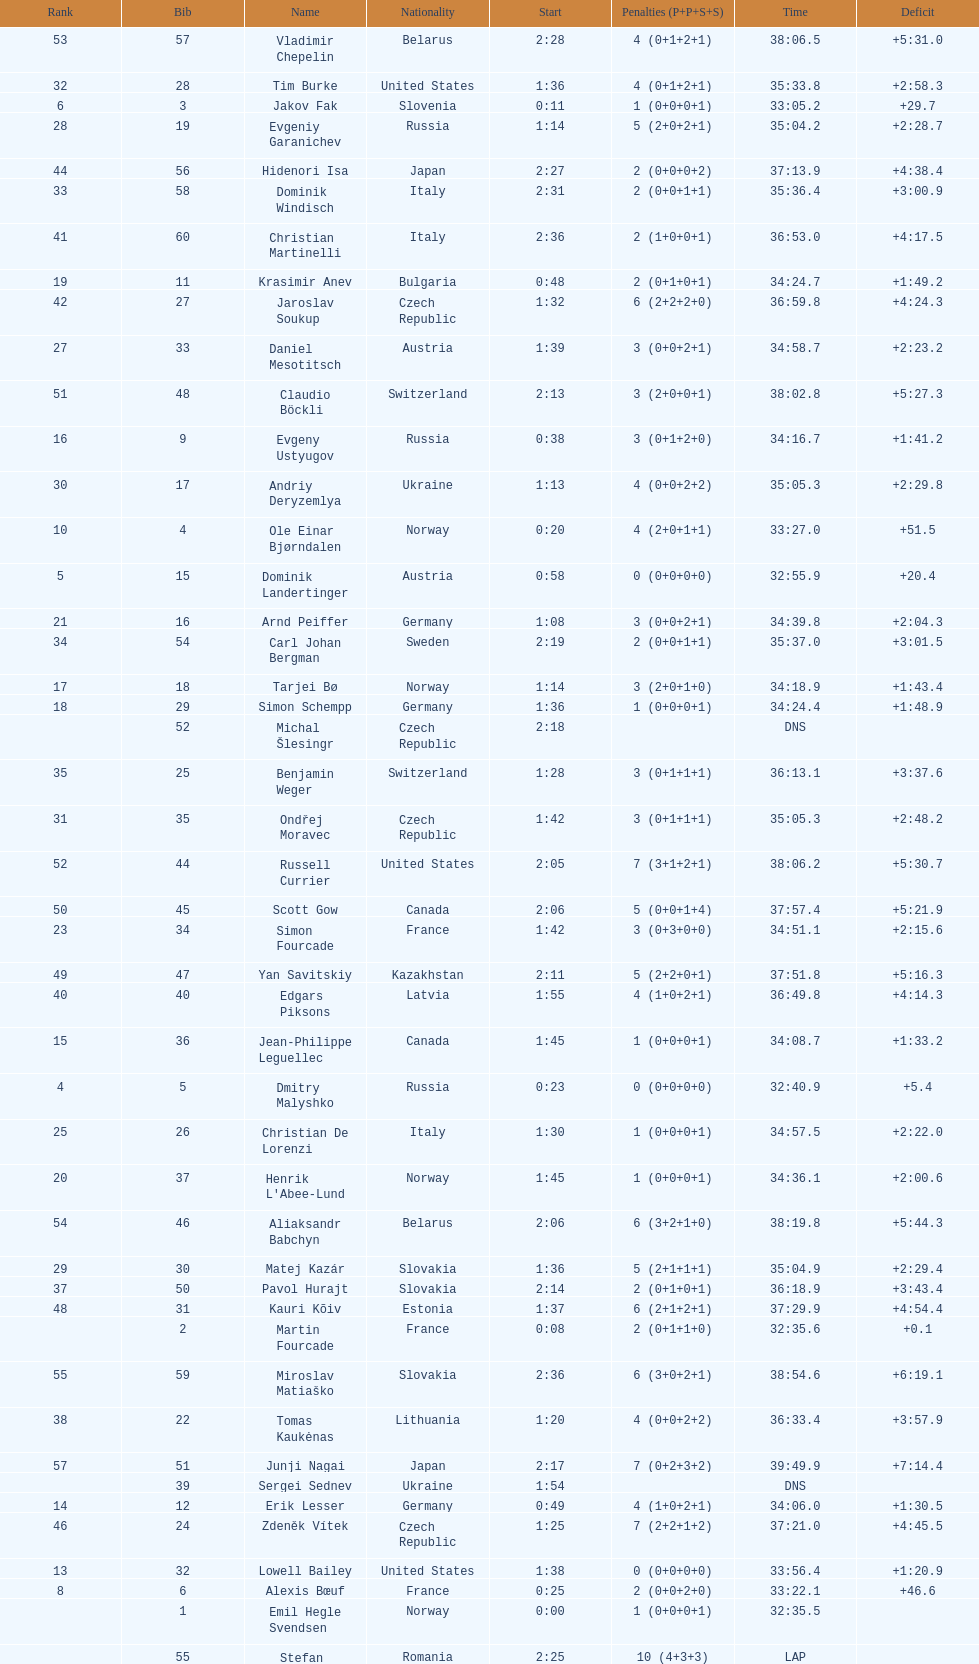What is the total number of participants between norway and france? 7. 